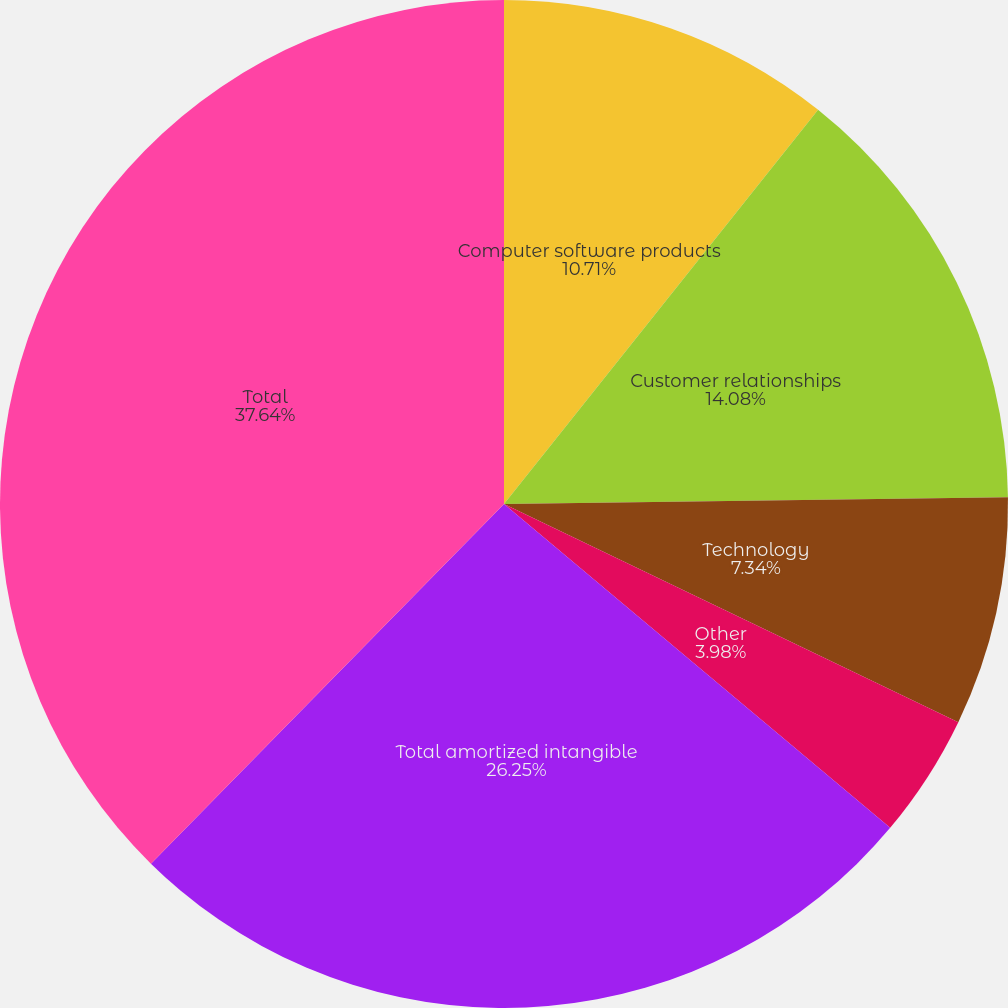Convert chart. <chart><loc_0><loc_0><loc_500><loc_500><pie_chart><fcel>Computer software products<fcel>Customer relationships<fcel>Technology<fcel>Other<fcel>Total amortized intangible<fcel>Total<nl><fcel>10.71%<fcel>14.08%<fcel>7.34%<fcel>3.98%<fcel>26.25%<fcel>37.65%<nl></chart> 